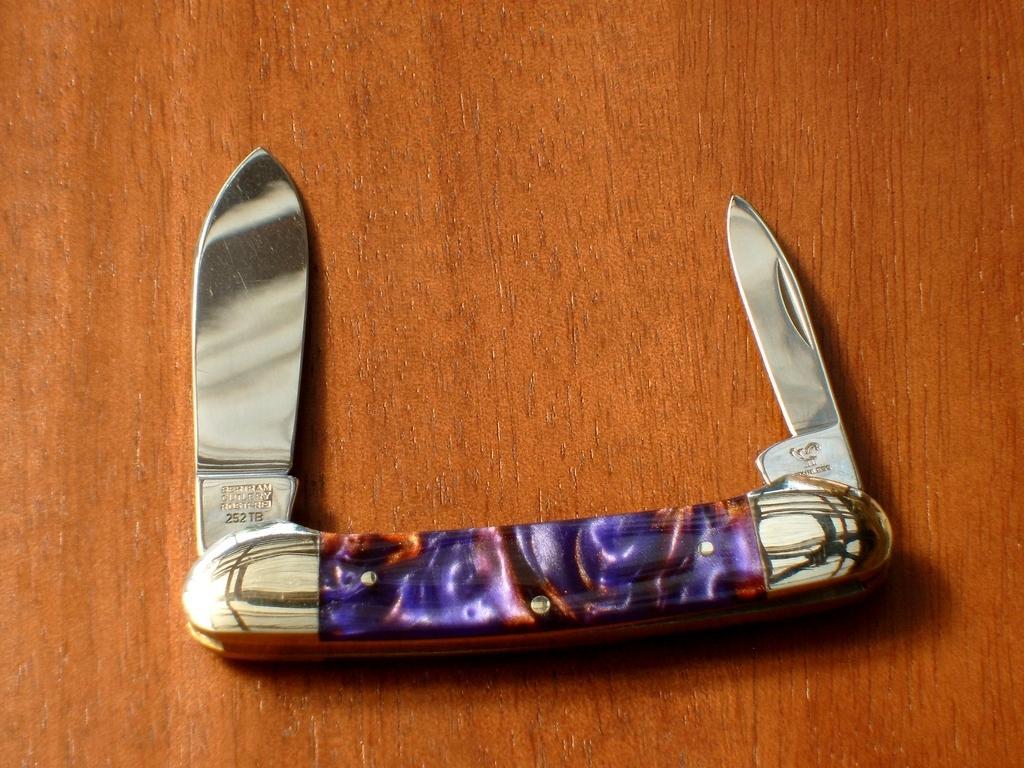Can you describe this image briefly? In this image there is a knife, which is on the brown colour surface. 